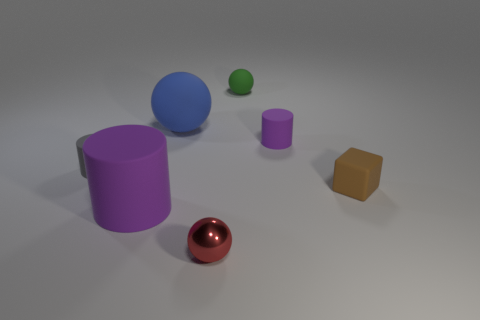Add 2 brown rubber things. How many objects exist? 9 Subtract all blocks. How many objects are left? 6 Add 7 big purple things. How many big purple things are left? 8 Add 7 small purple blocks. How many small purple blocks exist? 7 Subtract 1 blue spheres. How many objects are left? 6 Subtract all small gray cylinders. Subtract all small matte cylinders. How many objects are left? 4 